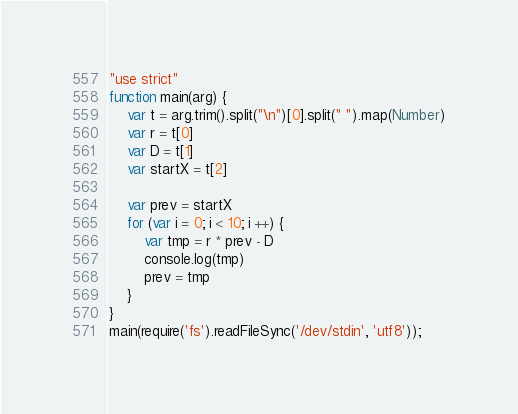Convert code to text. <code><loc_0><loc_0><loc_500><loc_500><_JavaScript_>"use strict"
function main(arg) {
    var t = arg.trim().split("\n")[0].split(" ").map(Number)
    var r = t[0]
    var D = t[1]
    var startX = t[2]

    var prev = startX
    for (var i = 0; i < 10; i ++) {
        var tmp = r * prev - D
        console.log(tmp)
        prev = tmp
    }
}
main(require('fs').readFileSync('/dev/stdin', 'utf8'));</code> 